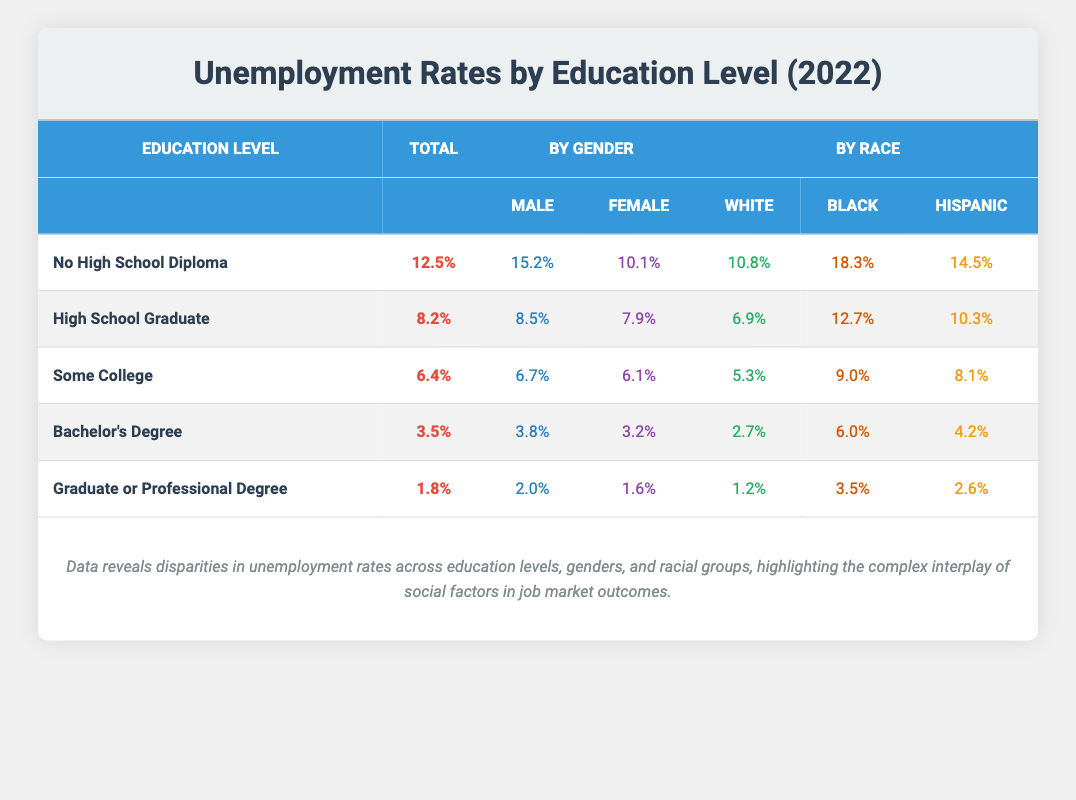What is the total unemployment rate for individuals with a Bachelor's Degree? The table indicates that the unemployment rate for individuals with a Bachelor's Degree is listed as 3.5%. This value can be directly found in the total column corresponding to that education level.
Answer: 3.5% Which demographic group has the highest unemployment rate among those with no high school diploma? The table shows that the unemployment rate for Black individuals with no high school diploma is 18.3%, which is the highest compared to White (10.8%) and Hispanic (14.5%) groups, as seen in the race-specific rates within that row.
Answer: Black individuals What is the difference in unemployment rates between males and females for those with a graduate or professional degree? For those with a graduate or professional degree, the unemployment rate for males is 2.0% and for females is 1.6%. To find the difference, subtract the female rate from the male rate: 2.0% - 1.6% = 0.4%.
Answer: 0.4% Is the unemployment rate for Hispanic individuals higher than that for White individuals across all education levels? Analyzing the data, Hispanic unemployment rates are assessed as follows: 14.5% (no diploma), 10.3% (high school), 8.1% (some college), 4.2% (Bachelor's), and 2.6% (graduate). For White individuals, the rates are 10.8%, 6.9%, 5.3%, 2.7%, and 1.2%. In the no diploma and high school categories, Hispanic rates are higher, but they are lower for Bachelor's and graduate/professional degrees. Therefore, the statement is false.
Answer: No What is the average unemployment rate for individuals who graduated high school, have some college education, and possess a Bachelor's Degree? The unemployment rates for these education levels are: High School Graduate (8.2%), Some College (6.4%), and Bachelor's Degree (3.5%). To find the average, sum these values: 8.2% + 6.4% + 3.5% = 18.1%. Then divide by the number of education levels (3): 18.1% / 3 = 6.03%.
Answer: 6.03% Do females have a lower unemployment rate than males across all education levels listed? By comparing the unemployment rates for males and females in the table, the values are as follows: For no diploma, males (15.2%) and females (10.1%); high school, males (8.5%) and females (7.9%); some college, males (6.7%) and females (6.1%); Bachelor's, males (3.8%) and females (3.2%); graduate, males (2.0%) and females (1.6%). In each case, females have a lower rate compared to males. Thus, the statement is true.
Answer: Yes 